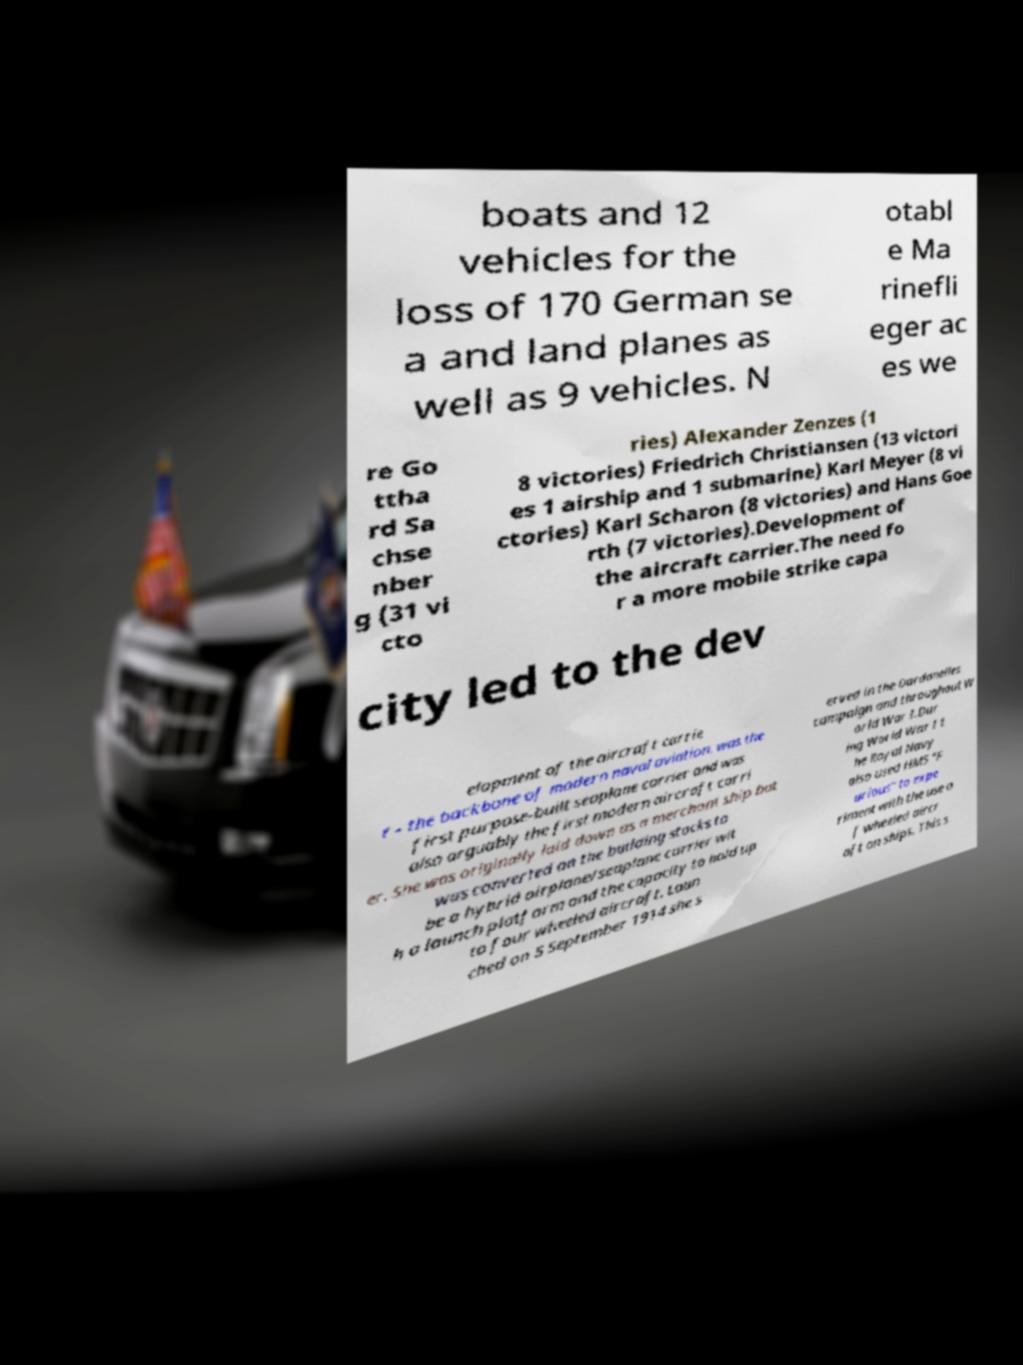There's text embedded in this image that I need extracted. Can you transcribe it verbatim? boats and 12 vehicles for the loss of 170 German se a and land planes as well as 9 vehicles. N otabl e Ma rinefli eger ac es we re Go ttha rd Sa chse nber g (31 vi cto ries) Alexander Zenzes (1 8 victories) Friedrich Christiansen (13 victori es 1 airship and 1 submarine) Karl Meyer (8 vi ctories) Karl Scharon (8 victories) and Hans Goe rth (7 victories).Development of the aircraft carrier.The need fo r a more mobile strike capa city led to the dev elopment of the aircraft carrie r - the backbone of modern naval aviation. was the first purpose-built seaplane carrier and was also arguably the first modern aircraft carri er. She was originally laid down as a merchant ship but was converted on the building stocks to be a hybrid airplane/seaplane carrier wit h a launch platform and the capacity to hold up to four wheeled aircraft. Laun ched on 5 September 1914 she s erved in the Dardanelles campaign and throughout W orld War I.Dur ing World War I t he Royal Navy also used HMS "F urious" to expe riment with the use o f wheeled aircr aft on ships. This s 